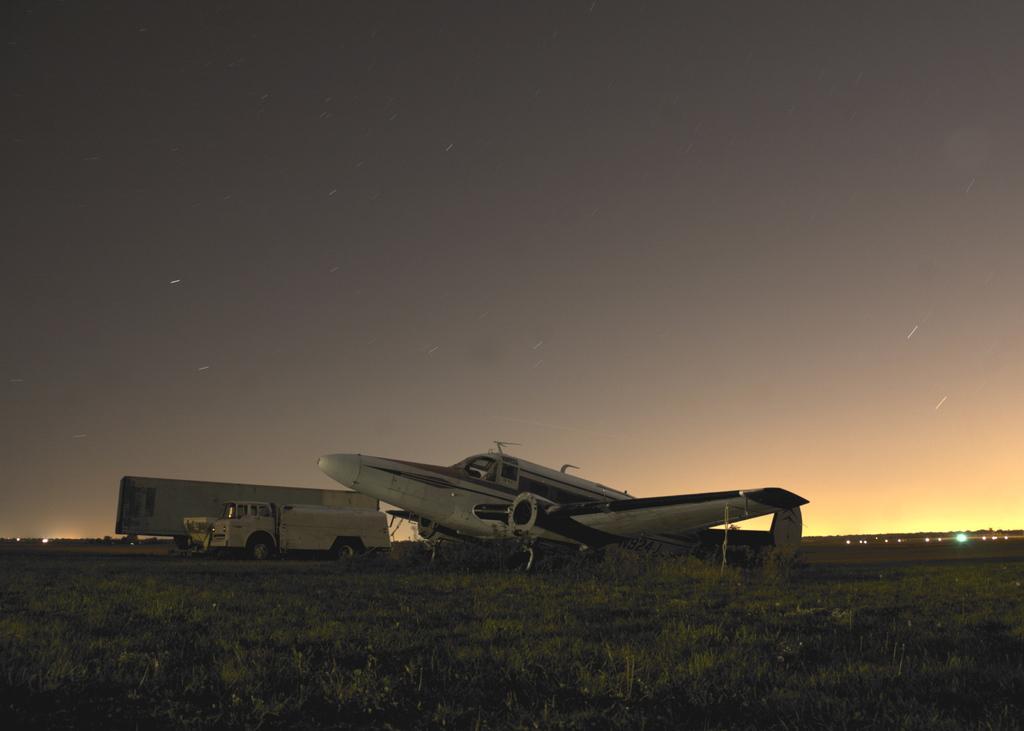In one or two sentences, can you explain what this image depicts? As we can see in the image the ground is covered with grass. There is an aeroplane standing on the land beside it there is a truck and beside the truck there is another vehicle standing and on the above there is a clear sky and back of the aeroplane and vehicles there are lights on the road. 